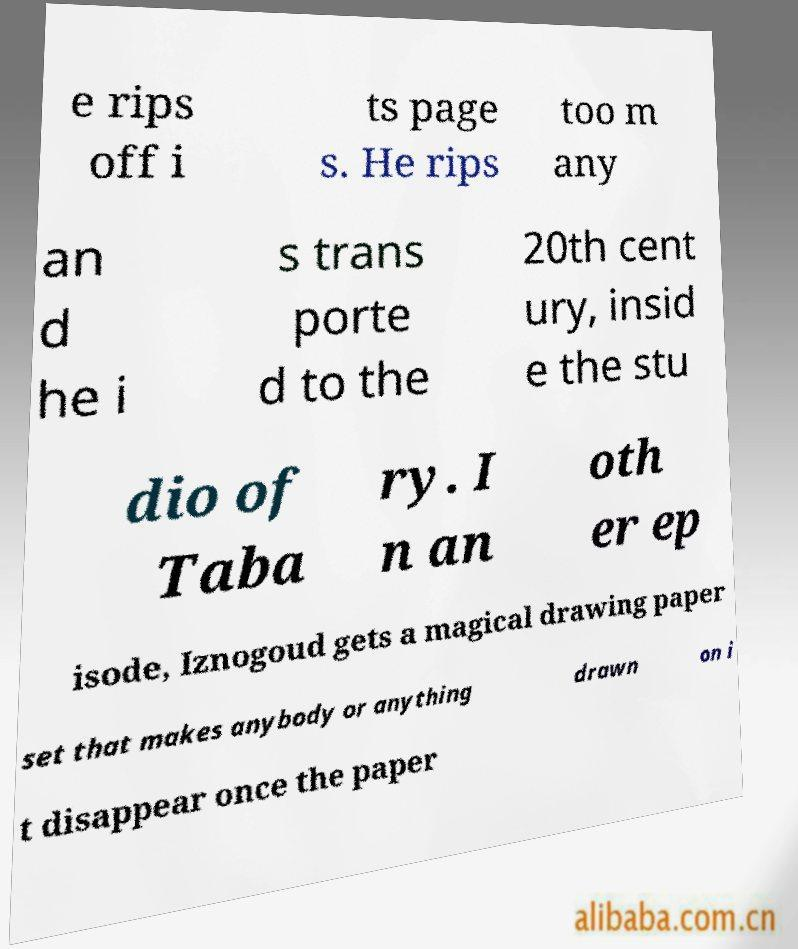There's text embedded in this image that I need extracted. Can you transcribe it verbatim? e rips off i ts page s. He rips too m any an d he i s trans porte d to the 20th cent ury, insid e the stu dio of Taba ry. I n an oth er ep isode, Iznogoud gets a magical drawing paper set that makes anybody or anything drawn on i t disappear once the paper 